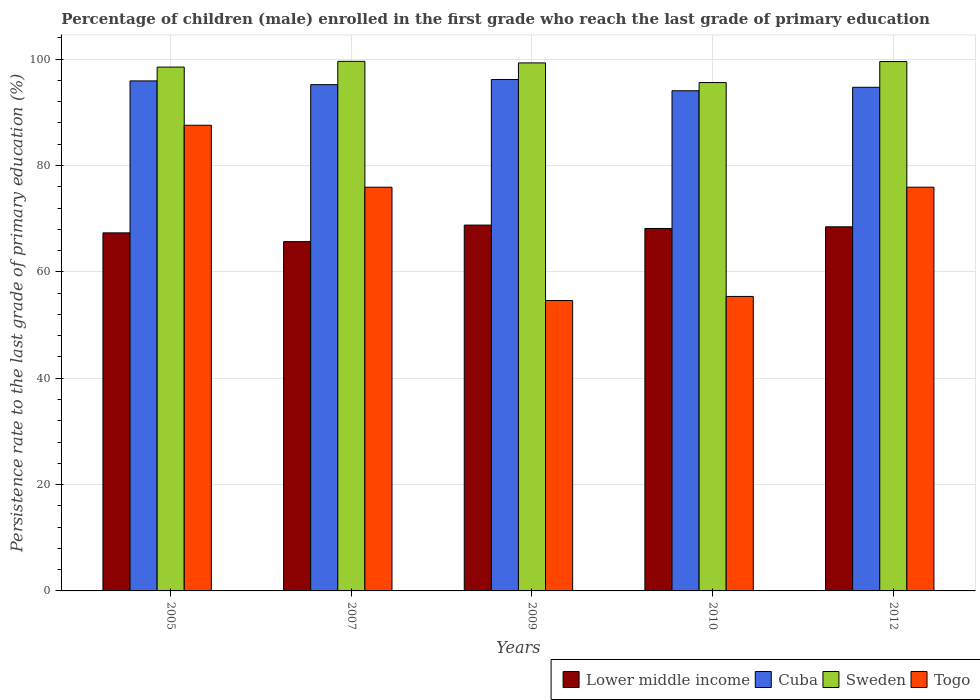How many different coloured bars are there?
Your response must be concise. 4. How many groups of bars are there?
Give a very brief answer. 5. Are the number of bars per tick equal to the number of legend labels?
Offer a terse response. Yes. How many bars are there on the 2nd tick from the left?
Your response must be concise. 4. How many bars are there on the 5th tick from the right?
Ensure brevity in your answer.  4. What is the label of the 1st group of bars from the left?
Your answer should be very brief. 2005. In how many cases, is the number of bars for a given year not equal to the number of legend labels?
Make the answer very short. 0. What is the persistence rate of children in Togo in 2010?
Your response must be concise. 55.38. Across all years, what is the maximum persistence rate of children in Cuba?
Provide a short and direct response. 96.16. Across all years, what is the minimum persistence rate of children in Lower middle income?
Ensure brevity in your answer.  65.68. In which year was the persistence rate of children in Lower middle income maximum?
Make the answer very short. 2009. What is the total persistence rate of children in Togo in the graph?
Keep it short and to the point. 349.37. What is the difference between the persistence rate of children in Cuba in 2010 and that in 2012?
Provide a short and direct response. -0.65. What is the difference between the persistence rate of children in Sweden in 2007 and the persistence rate of children in Lower middle income in 2010?
Give a very brief answer. 31.43. What is the average persistence rate of children in Cuba per year?
Offer a terse response. 95.2. In the year 2005, what is the difference between the persistence rate of children in Sweden and persistence rate of children in Togo?
Your response must be concise. 10.94. In how many years, is the persistence rate of children in Sweden greater than 76 %?
Your answer should be very brief. 5. What is the ratio of the persistence rate of children in Lower middle income in 2005 to that in 2009?
Ensure brevity in your answer.  0.98. Is the persistence rate of children in Sweden in 2009 less than that in 2010?
Provide a short and direct response. No. What is the difference between the highest and the second highest persistence rate of children in Togo?
Your answer should be very brief. 11.65. What is the difference between the highest and the lowest persistence rate of children in Cuba?
Offer a very short reply. 2.11. In how many years, is the persistence rate of children in Togo greater than the average persistence rate of children in Togo taken over all years?
Provide a succinct answer. 3. What does the 2nd bar from the left in 2012 represents?
Keep it short and to the point. Cuba. What does the 4th bar from the right in 2010 represents?
Make the answer very short. Lower middle income. How many years are there in the graph?
Provide a short and direct response. 5. Does the graph contain any zero values?
Offer a terse response. No. Does the graph contain grids?
Your answer should be very brief. Yes. Where does the legend appear in the graph?
Make the answer very short. Bottom right. How are the legend labels stacked?
Offer a terse response. Horizontal. What is the title of the graph?
Give a very brief answer. Percentage of children (male) enrolled in the first grade who reach the last grade of primary education. Does "Central Europe" appear as one of the legend labels in the graph?
Give a very brief answer. No. What is the label or title of the X-axis?
Your response must be concise. Years. What is the label or title of the Y-axis?
Offer a very short reply. Persistence rate to the last grade of primary education (%). What is the Persistence rate to the last grade of primary education (%) of Lower middle income in 2005?
Your answer should be compact. 67.33. What is the Persistence rate to the last grade of primary education (%) of Cuba in 2005?
Ensure brevity in your answer.  95.9. What is the Persistence rate to the last grade of primary education (%) in Sweden in 2005?
Provide a short and direct response. 98.5. What is the Persistence rate to the last grade of primary education (%) in Togo in 2005?
Provide a succinct answer. 87.56. What is the Persistence rate to the last grade of primary education (%) of Lower middle income in 2007?
Provide a succinct answer. 65.68. What is the Persistence rate to the last grade of primary education (%) of Cuba in 2007?
Your response must be concise. 95.2. What is the Persistence rate to the last grade of primary education (%) of Sweden in 2007?
Keep it short and to the point. 99.58. What is the Persistence rate to the last grade of primary education (%) of Togo in 2007?
Your answer should be very brief. 75.91. What is the Persistence rate to the last grade of primary education (%) in Lower middle income in 2009?
Your answer should be compact. 68.79. What is the Persistence rate to the last grade of primary education (%) of Cuba in 2009?
Offer a very short reply. 96.16. What is the Persistence rate to the last grade of primary education (%) in Sweden in 2009?
Provide a short and direct response. 99.29. What is the Persistence rate to the last grade of primary education (%) of Togo in 2009?
Your answer should be compact. 54.61. What is the Persistence rate to the last grade of primary education (%) in Lower middle income in 2010?
Provide a succinct answer. 68.15. What is the Persistence rate to the last grade of primary education (%) of Cuba in 2010?
Ensure brevity in your answer.  94.05. What is the Persistence rate to the last grade of primary education (%) of Sweden in 2010?
Your answer should be compact. 95.59. What is the Persistence rate to the last grade of primary education (%) of Togo in 2010?
Offer a very short reply. 55.38. What is the Persistence rate to the last grade of primary education (%) of Lower middle income in 2012?
Your answer should be compact. 68.47. What is the Persistence rate to the last grade of primary education (%) in Cuba in 2012?
Keep it short and to the point. 94.7. What is the Persistence rate to the last grade of primary education (%) of Sweden in 2012?
Keep it short and to the point. 99.54. What is the Persistence rate to the last grade of primary education (%) in Togo in 2012?
Offer a very short reply. 75.91. Across all years, what is the maximum Persistence rate to the last grade of primary education (%) of Lower middle income?
Offer a very short reply. 68.79. Across all years, what is the maximum Persistence rate to the last grade of primary education (%) in Cuba?
Your response must be concise. 96.16. Across all years, what is the maximum Persistence rate to the last grade of primary education (%) in Sweden?
Provide a succinct answer. 99.58. Across all years, what is the maximum Persistence rate to the last grade of primary education (%) in Togo?
Offer a very short reply. 87.56. Across all years, what is the minimum Persistence rate to the last grade of primary education (%) in Lower middle income?
Your answer should be very brief. 65.68. Across all years, what is the minimum Persistence rate to the last grade of primary education (%) in Cuba?
Offer a terse response. 94.05. Across all years, what is the minimum Persistence rate to the last grade of primary education (%) of Sweden?
Keep it short and to the point. 95.59. Across all years, what is the minimum Persistence rate to the last grade of primary education (%) of Togo?
Provide a succinct answer. 54.61. What is the total Persistence rate to the last grade of primary education (%) in Lower middle income in the graph?
Your answer should be compact. 338.42. What is the total Persistence rate to the last grade of primary education (%) in Cuba in the graph?
Your answer should be very brief. 476.01. What is the total Persistence rate to the last grade of primary education (%) of Sweden in the graph?
Provide a short and direct response. 492.49. What is the total Persistence rate to the last grade of primary education (%) of Togo in the graph?
Offer a terse response. 349.37. What is the difference between the Persistence rate to the last grade of primary education (%) in Lower middle income in 2005 and that in 2007?
Offer a very short reply. 1.65. What is the difference between the Persistence rate to the last grade of primary education (%) in Cuba in 2005 and that in 2007?
Keep it short and to the point. 0.7. What is the difference between the Persistence rate to the last grade of primary education (%) in Sweden in 2005 and that in 2007?
Your answer should be compact. -1.08. What is the difference between the Persistence rate to the last grade of primary education (%) of Togo in 2005 and that in 2007?
Your answer should be very brief. 11.65. What is the difference between the Persistence rate to the last grade of primary education (%) in Lower middle income in 2005 and that in 2009?
Ensure brevity in your answer.  -1.46. What is the difference between the Persistence rate to the last grade of primary education (%) of Cuba in 2005 and that in 2009?
Give a very brief answer. -0.26. What is the difference between the Persistence rate to the last grade of primary education (%) of Sweden in 2005 and that in 2009?
Ensure brevity in your answer.  -0.79. What is the difference between the Persistence rate to the last grade of primary education (%) in Togo in 2005 and that in 2009?
Provide a succinct answer. 32.96. What is the difference between the Persistence rate to the last grade of primary education (%) of Lower middle income in 2005 and that in 2010?
Keep it short and to the point. -0.82. What is the difference between the Persistence rate to the last grade of primary education (%) in Cuba in 2005 and that in 2010?
Your answer should be compact. 1.85. What is the difference between the Persistence rate to the last grade of primary education (%) in Sweden in 2005 and that in 2010?
Your answer should be very brief. 2.91. What is the difference between the Persistence rate to the last grade of primary education (%) of Togo in 2005 and that in 2010?
Your answer should be compact. 32.19. What is the difference between the Persistence rate to the last grade of primary education (%) in Lower middle income in 2005 and that in 2012?
Provide a succinct answer. -1.14. What is the difference between the Persistence rate to the last grade of primary education (%) of Cuba in 2005 and that in 2012?
Provide a succinct answer. 1.2. What is the difference between the Persistence rate to the last grade of primary education (%) in Sweden in 2005 and that in 2012?
Ensure brevity in your answer.  -1.04. What is the difference between the Persistence rate to the last grade of primary education (%) in Togo in 2005 and that in 2012?
Keep it short and to the point. 11.65. What is the difference between the Persistence rate to the last grade of primary education (%) of Lower middle income in 2007 and that in 2009?
Provide a succinct answer. -3.11. What is the difference between the Persistence rate to the last grade of primary education (%) of Cuba in 2007 and that in 2009?
Ensure brevity in your answer.  -0.97. What is the difference between the Persistence rate to the last grade of primary education (%) in Sweden in 2007 and that in 2009?
Provide a short and direct response. 0.29. What is the difference between the Persistence rate to the last grade of primary education (%) of Togo in 2007 and that in 2009?
Your answer should be very brief. 21.31. What is the difference between the Persistence rate to the last grade of primary education (%) in Lower middle income in 2007 and that in 2010?
Make the answer very short. -2.47. What is the difference between the Persistence rate to the last grade of primary education (%) in Cuba in 2007 and that in 2010?
Provide a succinct answer. 1.15. What is the difference between the Persistence rate to the last grade of primary education (%) of Sweden in 2007 and that in 2010?
Ensure brevity in your answer.  3.99. What is the difference between the Persistence rate to the last grade of primary education (%) in Togo in 2007 and that in 2010?
Keep it short and to the point. 20.54. What is the difference between the Persistence rate to the last grade of primary education (%) in Lower middle income in 2007 and that in 2012?
Your answer should be very brief. -2.78. What is the difference between the Persistence rate to the last grade of primary education (%) in Cuba in 2007 and that in 2012?
Ensure brevity in your answer.  0.5. What is the difference between the Persistence rate to the last grade of primary education (%) in Sweden in 2007 and that in 2012?
Make the answer very short. 0.04. What is the difference between the Persistence rate to the last grade of primary education (%) of Togo in 2007 and that in 2012?
Offer a terse response. -0. What is the difference between the Persistence rate to the last grade of primary education (%) of Lower middle income in 2009 and that in 2010?
Provide a succinct answer. 0.64. What is the difference between the Persistence rate to the last grade of primary education (%) in Cuba in 2009 and that in 2010?
Make the answer very short. 2.11. What is the difference between the Persistence rate to the last grade of primary education (%) of Sweden in 2009 and that in 2010?
Make the answer very short. 3.7. What is the difference between the Persistence rate to the last grade of primary education (%) in Togo in 2009 and that in 2010?
Provide a succinct answer. -0.77. What is the difference between the Persistence rate to the last grade of primary education (%) of Lower middle income in 2009 and that in 2012?
Offer a terse response. 0.32. What is the difference between the Persistence rate to the last grade of primary education (%) of Cuba in 2009 and that in 2012?
Offer a terse response. 1.46. What is the difference between the Persistence rate to the last grade of primary education (%) of Sweden in 2009 and that in 2012?
Your response must be concise. -0.25. What is the difference between the Persistence rate to the last grade of primary education (%) of Togo in 2009 and that in 2012?
Provide a succinct answer. -21.31. What is the difference between the Persistence rate to the last grade of primary education (%) of Lower middle income in 2010 and that in 2012?
Give a very brief answer. -0.31. What is the difference between the Persistence rate to the last grade of primary education (%) in Cuba in 2010 and that in 2012?
Your answer should be compact. -0.65. What is the difference between the Persistence rate to the last grade of primary education (%) of Sweden in 2010 and that in 2012?
Give a very brief answer. -3.95. What is the difference between the Persistence rate to the last grade of primary education (%) of Togo in 2010 and that in 2012?
Offer a terse response. -20.54. What is the difference between the Persistence rate to the last grade of primary education (%) of Lower middle income in 2005 and the Persistence rate to the last grade of primary education (%) of Cuba in 2007?
Offer a very short reply. -27.87. What is the difference between the Persistence rate to the last grade of primary education (%) in Lower middle income in 2005 and the Persistence rate to the last grade of primary education (%) in Sweden in 2007?
Your response must be concise. -32.25. What is the difference between the Persistence rate to the last grade of primary education (%) of Lower middle income in 2005 and the Persistence rate to the last grade of primary education (%) of Togo in 2007?
Make the answer very short. -8.59. What is the difference between the Persistence rate to the last grade of primary education (%) of Cuba in 2005 and the Persistence rate to the last grade of primary education (%) of Sweden in 2007?
Provide a short and direct response. -3.68. What is the difference between the Persistence rate to the last grade of primary education (%) in Cuba in 2005 and the Persistence rate to the last grade of primary education (%) in Togo in 2007?
Make the answer very short. 19.99. What is the difference between the Persistence rate to the last grade of primary education (%) of Sweden in 2005 and the Persistence rate to the last grade of primary education (%) of Togo in 2007?
Make the answer very short. 22.59. What is the difference between the Persistence rate to the last grade of primary education (%) in Lower middle income in 2005 and the Persistence rate to the last grade of primary education (%) in Cuba in 2009?
Provide a succinct answer. -28.83. What is the difference between the Persistence rate to the last grade of primary education (%) in Lower middle income in 2005 and the Persistence rate to the last grade of primary education (%) in Sweden in 2009?
Your answer should be compact. -31.96. What is the difference between the Persistence rate to the last grade of primary education (%) in Lower middle income in 2005 and the Persistence rate to the last grade of primary education (%) in Togo in 2009?
Ensure brevity in your answer.  12.72. What is the difference between the Persistence rate to the last grade of primary education (%) in Cuba in 2005 and the Persistence rate to the last grade of primary education (%) in Sweden in 2009?
Your answer should be compact. -3.38. What is the difference between the Persistence rate to the last grade of primary education (%) in Cuba in 2005 and the Persistence rate to the last grade of primary education (%) in Togo in 2009?
Provide a succinct answer. 41.3. What is the difference between the Persistence rate to the last grade of primary education (%) of Sweden in 2005 and the Persistence rate to the last grade of primary education (%) of Togo in 2009?
Your response must be concise. 43.89. What is the difference between the Persistence rate to the last grade of primary education (%) of Lower middle income in 2005 and the Persistence rate to the last grade of primary education (%) of Cuba in 2010?
Provide a succinct answer. -26.72. What is the difference between the Persistence rate to the last grade of primary education (%) of Lower middle income in 2005 and the Persistence rate to the last grade of primary education (%) of Sweden in 2010?
Give a very brief answer. -28.26. What is the difference between the Persistence rate to the last grade of primary education (%) in Lower middle income in 2005 and the Persistence rate to the last grade of primary education (%) in Togo in 2010?
Provide a succinct answer. 11.95. What is the difference between the Persistence rate to the last grade of primary education (%) in Cuba in 2005 and the Persistence rate to the last grade of primary education (%) in Sweden in 2010?
Make the answer very short. 0.31. What is the difference between the Persistence rate to the last grade of primary education (%) of Cuba in 2005 and the Persistence rate to the last grade of primary education (%) of Togo in 2010?
Provide a succinct answer. 40.52. What is the difference between the Persistence rate to the last grade of primary education (%) in Sweden in 2005 and the Persistence rate to the last grade of primary education (%) in Togo in 2010?
Offer a terse response. 43.12. What is the difference between the Persistence rate to the last grade of primary education (%) of Lower middle income in 2005 and the Persistence rate to the last grade of primary education (%) of Cuba in 2012?
Give a very brief answer. -27.37. What is the difference between the Persistence rate to the last grade of primary education (%) of Lower middle income in 2005 and the Persistence rate to the last grade of primary education (%) of Sweden in 2012?
Make the answer very short. -32.21. What is the difference between the Persistence rate to the last grade of primary education (%) in Lower middle income in 2005 and the Persistence rate to the last grade of primary education (%) in Togo in 2012?
Your response must be concise. -8.59. What is the difference between the Persistence rate to the last grade of primary education (%) in Cuba in 2005 and the Persistence rate to the last grade of primary education (%) in Sweden in 2012?
Provide a succinct answer. -3.64. What is the difference between the Persistence rate to the last grade of primary education (%) of Cuba in 2005 and the Persistence rate to the last grade of primary education (%) of Togo in 2012?
Offer a terse response. 19.99. What is the difference between the Persistence rate to the last grade of primary education (%) in Sweden in 2005 and the Persistence rate to the last grade of primary education (%) in Togo in 2012?
Keep it short and to the point. 22.58. What is the difference between the Persistence rate to the last grade of primary education (%) of Lower middle income in 2007 and the Persistence rate to the last grade of primary education (%) of Cuba in 2009?
Give a very brief answer. -30.48. What is the difference between the Persistence rate to the last grade of primary education (%) in Lower middle income in 2007 and the Persistence rate to the last grade of primary education (%) in Sweden in 2009?
Offer a terse response. -33.6. What is the difference between the Persistence rate to the last grade of primary education (%) in Lower middle income in 2007 and the Persistence rate to the last grade of primary education (%) in Togo in 2009?
Give a very brief answer. 11.08. What is the difference between the Persistence rate to the last grade of primary education (%) in Cuba in 2007 and the Persistence rate to the last grade of primary education (%) in Sweden in 2009?
Give a very brief answer. -4.09. What is the difference between the Persistence rate to the last grade of primary education (%) in Cuba in 2007 and the Persistence rate to the last grade of primary education (%) in Togo in 2009?
Provide a short and direct response. 40.59. What is the difference between the Persistence rate to the last grade of primary education (%) of Sweden in 2007 and the Persistence rate to the last grade of primary education (%) of Togo in 2009?
Your response must be concise. 44.97. What is the difference between the Persistence rate to the last grade of primary education (%) in Lower middle income in 2007 and the Persistence rate to the last grade of primary education (%) in Cuba in 2010?
Offer a terse response. -28.37. What is the difference between the Persistence rate to the last grade of primary education (%) in Lower middle income in 2007 and the Persistence rate to the last grade of primary education (%) in Sweden in 2010?
Your response must be concise. -29.91. What is the difference between the Persistence rate to the last grade of primary education (%) of Lower middle income in 2007 and the Persistence rate to the last grade of primary education (%) of Togo in 2010?
Your response must be concise. 10.31. What is the difference between the Persistence rate to the last grade of primary education (%) of Cuba in 2007 and the Persistence rate to the last grade of primary education (%) of Sweden in 2010?
Your answer should be very brief. -0.39. What is the difference between the Persistence rate to the last grade of primary education (%) in Cuba in 2007 and the Persistence rate to the last grade of primary education (%) in Togo in 2010?
Offer a terse response. 39.82. What is the difference between the Persistence rate to the last grade of primary education (%) of Sweden in 2007 and the Persistence rate to the last grade of primary education (%) of Togo in 2010?
Provide a succinct answer. 44.2. What is the difference between the Persistence rate to the last grade of primary education (%) of Lower middle income in 2007 and the Persistence rate to the last grade of primary education (%) of Cuba in 2012?
Offer a terse response. -29.02. What is the difference between the Persistence rate to the last grade of primary education (%) in Lower middle income in 2007 and the Persistence rate to the last grade of primary education (%) in Sweden in 2012?
Keep it short and to the point. -33.86. What is the difference between the Persistence rate to the last grade of primary education (%) in Lower middle income in 2007 and the Persistence rate to the last grade of primary education (%) in Togo in 2012?
Keep it short and to the point. -10.23. What is the difference between the Persistence rate to the last grade of primary education (%) in Cuba in 2007 and the Persistence rate to the last grade of primary education (%) in Sweden in 2012?
Offer a terse response. -4.34. What is the difference between the Persistence rate to the last grade of primary education (%) of Cuba in 2007 and the Persistence rate to the last grade of primary education (%) of Togo in 2012?
Keep it short and to the point. 19.28. What is the difference between the Persistence rate to the last grade of primary education (%) of Sweden in 2007 and the Persistence rate to the last grade of primary education (%) of Togo in 2012?
Offer a very short reply. 23.66. What is the difference between the Persistence rate to the last grade of primary education (%) of Lower middle income in 2009 and the Persistence rate to the last grade of primary education (%) of Cuba in 2010?
Your answer should be compact. -25.26. What is the difference between the Persistence rate to the last grade of primary education (%) of Lower middle income in 2009 and the Persistence rate to the last grade of primary education (%) of Sweden in 2010?
Provide a succinct answer. -26.8. What is the difference between the Persistence rate to the last grade of primary education (%) in Lower middle income in 2009 and the Persistence rate to the last grade of primary education (%) in Togo in 2010?
Ensure brevity in your answer.  13.41. What is the difference between the Persistence rate to the last grade of primary education (%) in Cuba in 2009 and the Persistence rate to the last grade of primary education (%) in Sweden in 2010?
Give a very brief answer. 0.57. What is the difference between the Persistence rate to the last grade of primary education (%) in Cuba in 2009 and the Persistence rate to the last grade of primary education (%) in Togo in 2010?
Offer a very short reply. 40.79. What is the difference between the Persistence rate to the last grade of primary education (%) of Sweden in 2009 and the Persistence rate to the last grade of primary education (%) of Togo in 2010?
Provide a succinct answer. 43.91. What is the difference between the Persistence rate to the last grade of primary education (%) in Lower middle income in 2009 and the Persistence rate to the last grade of primary education (%) in Cuba in 2012?
Offer a very short reply. -25.91. What is the difference between the Persistence rate to the last grade of primary education (%) in Lower middle income in 2009 and the Persistence rate to the last grade of primary education (%) in Sweden in 2012?
Provide a short and direct response. -30.75. What is the difference between the Persistence rate to the last grade of primary education (%) of Lower middle income in 2009 and the Persistence rate to the last grade of primary education (%) of Togo in 2012?
Ensure brevity in your answer.  -7.12. What is the difference between the Persistence rate to the last grade of primary education (%) in Cuba in 2009 and the Persistence rate to the last grade of primary education (%) in Sweden in 2012?
Make the answer very short. -3.38. What is the difference between the Persistence rate to the last grade of primary education (%) of Cuba in 2009 and the Persistence rate to the last grade of primary education (%) of Togo in 2012?
Ensure brevity in your answer.  20.25. What is the difference between the Persistence rate to the last grade of primary education (%) of Sweden in 2009 and the Persistence rate to the last grade of primary education (%) of Togo in 2012?
Ensure brevity in your answer.  23.37. What is the difference between the Persistence rate to the last grade of primary education (%) in Lower middle income in 2010 and the Persistence rate to the last grade of primary education (%) in Cuba in 2012?
Your answer should be compact. -26.55. What is the difference between the Persistence rate to the last grade of primary education (%) of Lower middle income in 2010 and the Persistence rate to the last grade of primary education (%) of Sweden in 2012?
Your answer should be very brief. -31.39. What is the difference between the Persistence rate to the last grade of primary education (%) of Lower middle income in 2010 and the Persistence rate to the last grade of primary education (%) of Togo in 2012?
Ensure brevity in your answer.  -7.76. What is the difference between the Persistence rate to the last grade of primary education (%) in Cuba in 2010 and the Persistence rate to the last grade of primary education (%) in Sweden in 2012?
Your response must be concise. -5.49. What is the difference between the Persistence rate to the last grade of primary education (%) of Cuba in 2010 and the Persistence rate to the last grade of primary education (%) of Togo in 2012?
Keep it short and to the point. 18.13. What is the difference between the Persistence rate to the last grade of primary education (%) in Sweden in 2010 and the Persistence rate to the last grade of primary education (%) in Togo in 2012?
Your answer should be compact. 19.68. What is the average Persistence rate to the last grade of primary education (%) of Lower middle income per year?
Make the answer very short. 67.68. What is the average Persistence rate to the last grade of primary education (%) of Cuba per year?
Your answer should be very brief. 95.2. What is the average Persistence rate to the last grade of primary education (%) in Sweden per year?
Ensure brevity in your answer.  98.5. What is the average Persistence rate to the last grade of primary education (%) in Togo per year?
Offer a terse response. 69.87. In the year 2005, what is the difference between the Persistence rate to the last grade of primary education (%) of Lower middle income and Persistence rate to the last grade of primary education (%) of Cuba?
Offer a very short reply. -28.57. In the year 2005, what is the difference between the Persistence rate to the last grade of primary education (%) of Lower middle income and Persistence rate to the last grade of primary education (%) of Sweden?
Provide a short and direct response. -31.17. In the year 2005, what is the difference between the Persistence rate to the last grade of primary education (%) in Lower middle income and Persistence rate to the last grade of primary education (%) in Togo?
Your response must be concise. -20.23. In the year 2005, what is the difference between the Persistence rate to the last grade of primary education (%) in Cuba and Persistence rate to the last grade of primary education (%) in Sweden?
Provide a short and direct response. -2.6. In the year 2005, what is the difference between the Persistence rate to the last grade of primary education (%) of Cuba and Persistence rate to the last grade of primary education (%) of Togo?
Offer a very short reply. 8.34. In the year 2005, what is the difference between the Persistence rate to the last grade of primary education (%) in Sweden and Persistence rate to the last grade of primary education (%) in Togo?
Offer a very short reply. 10.94. In the year 2007, what is the difference between the Persistence rate to the last grade of primary education (%) of Lower middle income and Persistence rate to the last grade of primary education (%) of Cuba?
Keep it short and to the point. -29.51. In the year 2007, what is the difference between the Persistence rate to the last grade of primary education (%) of Lower middle income and Persistence rate to the last grade of primary education (%) of Sweden?
Ensure brevity in your answer.  -33.9. In the year 2007, what is the difference between the Persistence rate to the last grade of primary education (%) of Lower middle income and Persistence rate to the last grade of primary education (%) of Togo?
Give a very brief answer. -10.23. In the year 2007, what is the difference between the Persistence rate to the last grade of primary education (%) of Cuba and Persistence rate to the last grade of primary education (%) of Sweden?
Your answer should be compact. -4.38. In the year 2007, what is the difference between the Persistence rate to the last grade of primary education (%) of Cuba and Persistence rate to the last grade of primary education (%) of Togo?
Give a very brief answer. 19.28. In the year 2007, what is the difference between the Persistence rate to the last grade of primary education (%) of Sweden and Persistence rate to the last grade of primary education (%) of Togo?
Keep it short and to the point. 23.66. In the year 2009, what is the difference between the Persistence rate to the last grade of primary education (%) in Lower middle income and Persistence rate to the last grade of primary education (%) in Cuba?
Your response must be concise. -27.37. In the year 2009, what is the difference between the Persistence rate to the last grade of primary education (%) of Lower middle income and Persistence rate to the last grade of primary education (%) of Sweden?
Your response must be concise. -30.5. In the year 2009, what is the difference between the Persistence rate to the last grade of primary education (%) of Lower middle income and Persistence rate to the last grade of primary education (%) of Togo?
Make the answer very short. 14.18. In the year 2009, what is the difference between the Persistence rate to the last grade of primary education (%) of Cuba and Persistence rate to the last grade of primary education (%) of Sweden?
Your answer should be very brief. -3.12. In the year 2009, what is the difference between the Persistence rate to the last grade of primary education (%) in Cuba and Persistence rate to the last grade of primary education (%) in Togo?
Your response must be concise. 41.56. In the year 2009, what is the difference between the Persistence rate to the last grade of primary education (%) in Sweden and Persistence rate to the last grade of primary education (%) in Togo?
Your answer should be very brief. 44.68. In the year 2010, what is the difference between the Persistence rate to the last grade of primary education (%) of Lower middle income and Persistence rate to the last grade of primary education (%) of Cuba?
Provide a succinct answer. -25.9. In the year 2010, what is the difference between the Persistence rate to the last grade of primary education (%) in Lower middle income and Persistence rate to the last grade of primary education (%) in Sweden?
Your response must be concise. -27.44. In the year 2010, what is the difference between the Persistence rate to the last grade of primary education (%) in Lower middle income and Persistence rate to the last grade of primary education (%) in Togo?
Make the answer very short. 12.78. In the year 2010, what is the difference between the Persistence rate to the last grade of primary education (%) in Cuba and Persistence rate to the last grade of primary education (%) in Sweden?
Your answer should be very brief. -1.54. In the year 2010, what is the difference between the Persistence rate to the last grade of primary education (%) in Cuba and Persistence rate to the last grade of primary education (%) in Togo?
Provide a short and direct response. 38.67. In the year 2010, what is the difference between the Persistence rate to the last grade of primary education (%) in Sweden and Persistence rate to the last grade of primary education (%) in Togo?
Provide a short and direct response. 40.21. In the year 2012, what is the difference between the Persistence rate to the last grade of primary education (%) of Lower middle income and Persistence rate to the last grade of primary education (%) of Cuba?
Provide a short and direct response. -26.23. In the year 2012, what is the difference between the Persistence rate to the last grade of primary education (%) of Lower middle income and Persistence rate to the last grade of primary education (%) of Sweden?
Offer a very short reply. -31.07. In the year 2012, what is the difference between the Persistence rate to the last grade of primary education (%) in Lower middle income and Persistence rate to the last grade of primary education (%) in Togo?
Give a very brief answer. -7.45. In the year 2012, what is the difference between the Persistence rate to the last grade of primary education (%) in Cuba and Persistence rate to the last grade of primary education (%) in Sweden?
Your answer should be very brief. -4.84. In the year 2012, what is the difference between the Persistence rate to the last grade of primary education (%) in Cuba and Persistence rate to the last grade of primary education (%) in Togo?
Your response must be concise. 18.79. In the year 2012, what is the difference between the Persistence rate to the last grade of primary education (%) in Sweden and Persistence rate to the last grade of primary education (%) in Togo?
Offer a very short reply. 23.63. What is the ratio of the Persistence rate to the last grade of primary education (%) in Lower middle income in 2005 to that in 2007?
Make the answer very short. 1.03. What is the ratio of the Persistence rate to the last grade of primary education (%) of Cuba in 2005 to that in 2007?
Your answer should be compact. 1.01. What is the ratio of the Persistence rate to the last grade of primary education (%) in Togo in 2005 to that in 2007?
Ensure brevity in your answer.  1.15. What is the ratio of the Persistence rate to the last grade of primary education (%) in Lower middle income in 2005 to that in 2009?
Keep it short and to the point. 0.98. What is the ratio of the Persistence rate to the last grade of primary education (%) of Sweden in 2005 to that in 2009?
Provide a succinct answer. 0.99. What is the ratio of the Persistence rate to the last grade of primary education (%) of Togo in 2005 to that in 2009?
Ensure brevity in your answer.  1.6. What is the ratio of the Persistence rate to the last grade of primary education (%) in Lower middle income in 2005 to that in 2010?
Keep it short and to the point. 0.99. What is the ratio of the Persistence rate to the last grade of primary education (%) in Cuba in 2005 to that in 2010?
Give a very brief answer. 1.02. What is the ratio of the Persistence rate to the last grade of primary education (%) of Sweden in 2005 to that in 2010?
Keep it short and to the point. 1.03. What is the ratio of the Persistence rate to the last grade of primary education (%) of Togo in 2005 to that in 2010?
Keep it short and to the point. 1.58. What is the ratio of the Persistence rate to the last grade of primary education (%) in Lower middle income in 2005 to that in 2012?
Offer a terse response. 0.98. What is the ratio of the Persistence rate to the last grade of primary education (%) in Cuba in 2005 to that in 2012?
Ensure brevity in your answer.  1.01. What is the ratio of the Persistence rate to the last grade of primary education (%) of Sweden in 2005 to that in 2012?
Offer a very short reply. 0.99. What is the ratio of the Persistence rate to the last grade of primary education (%) of Togo in 2005 to that in 2012?
Offer a very short reply. 1.15. What is the ratio of the Persistence rate to the last grade of primary education (%) in Lower middle income in 2007 to that in 2009?
Your answer should be compact. 0.95. What is the ratio of the Persistence rate to the last grade of primary education (%) in Cuba in 2007 to that in 2009?
Provide a succinct answer. 0.99. What is the ratio of the Persistence rate to the last grade of primary education (%) in Togo in 2007 to that in 2009?
Make the answer very short. 1.39. What is the ratio of the Persistence rate to the last grade of primary education (%) in Lower middle income in 2007 to that in 2010?
Make the answer very short. 0.96. What is the ratio of the Persistence rate to the last grade of primary education (%) in Cuba in 2007 to that in 2010?
Your answer should be compact. 1.01. What is the ratio of the Persistence rate to the last grade of primary education (%) of Sweden in 2007 to that in 2010?
Offer a very short reply. 1.04. What is the ratio of the Persistence rate to the last grade of primary education (%) in Togo in 2007 to that in 2010?
Provide a short and direct response. 1.37. What is the ratio of the Persistence rate to the last grade of primary education (%) in Lower middle income in 2007 to that in 2012?
Provide a succinct answer. 0.96. What is the ratio of the Persistence rate to the last grade of primary education (%) in Cuba in 2007 to that in 2012?
Ensure brevity in your answer.  1.01. What is the ratio of the Persistence rate to the last grade of primary education (%) in Sweden in 2007 to that in 2012?
Your response must be concise. 1. What is the ratio of the Persistence rate to the last grade of primary education (%) in Togo in 2007 to that in 2012?
Offer a very short reply. 1. What is the ratio of the Persistence rate to the last grade of primary education (%) in Lower middle income in 2009 to that in 2010?
Keep it short and to the point. 1.01. What is the ratio of the Persistence rate to the last grade of primary education (%) of Cuba in 2009 to that in 2010?
Provide a succinct answer. 1.02. What is the ratio of the Persistence rate to the last grade of primary education (%) of Sweden in 2009 to that in 2010?
Offer a terse response. 1.04. What is the ratio of the Persistence rate to the last grade of primary education (%) in Togo in 2009 to that in 2010?
Make the answer very short. 0.99. What is the ratio of the Persistence rate to the last grade of primary education (%) in Cuba in 2009 to that in 2012?
Provide a succinct answer. 1.02. What is the ratio of the Persistence rate to the last grade of primary education (%) of Sweden in 2009 to that in 2012?
Give a very brief answer. 1. What is the ratio of the Persistence rate to the last grade of primary education (%) of Togo in 2009 to that in 2012?
Give a very brief answer. 0.72. What is the ratio of the Persistence rate to the last grade of primary education (%) in Lower middle income in 2010 to that in 2012?
Your response must be concise. 1. What is the ratio of the Persistence rate to the last grade of primary education (%) of Sweden in 2010 to that in 2012?
Your answer should be very brief. 0.96. What is the ratio of the Persistence rate to the last grade of primary education (%) of Togo in 2010 to that in 2012?
Your answer should be compact. 0.73. What is the difference between the highest and the second highest Persistence rate to the last grade of primary education (%) of Lower middle income?
Offer a terse response. 0.32. What is the difference between the highest and the second highest Persistence rate to the last grade of primary education (%) in Cuba?
Offer a terse response. 0.26. What is the difference between the highest and the second highest Persistence rate to the last grade of primary education (%) of Sweden?
Provide a succinct answer. 0.04. What is the difference between the highest and the second highest Persistence rate to the last grade of primary education (%) of Togo?
Give a very brief answer. 11.65. What is the difference between the highest and the lowest Persistence rate to the last grade of primary education (%) of Lower middle income?
Ensure brevity in your answer.  3.11. What is the difference between the highest and the lowest Persistence rate to the last grade of primary education (%) of Cuba?
Keep it short and to the point. 2.11. What is the difference between the highest and the lowest Persistence rate to the last grade of primary education (%) of Sweden?
Provide a short and direct response. 3.99. What is the difference between the highest and the lowest Persistence rate to the last grade of primary education (%) of Togo?
Keep it short and to the point. 32.96. 